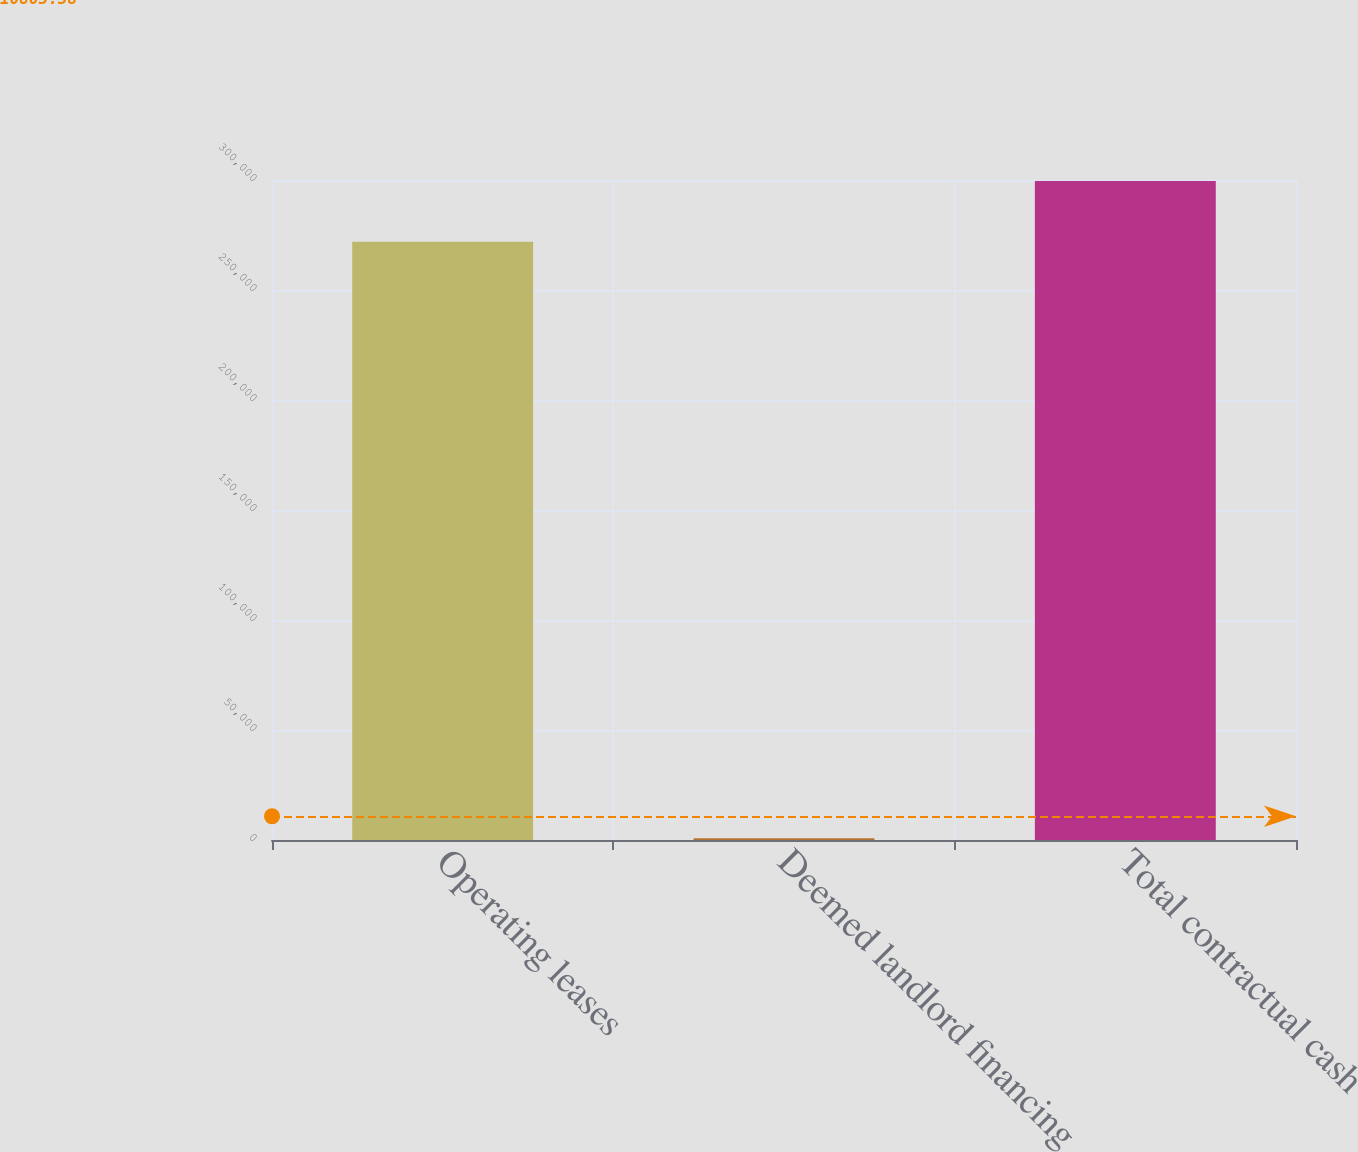Convert chart. <chart><loc_0><loc_0><loc_500><loc_500><bar_chart><fcel>Operating leases<fcel>Deemed landlord financing<fcel>Total contractual cash<nl><fcel>271911<fcel>788<fcel>299511<nl></chart> 